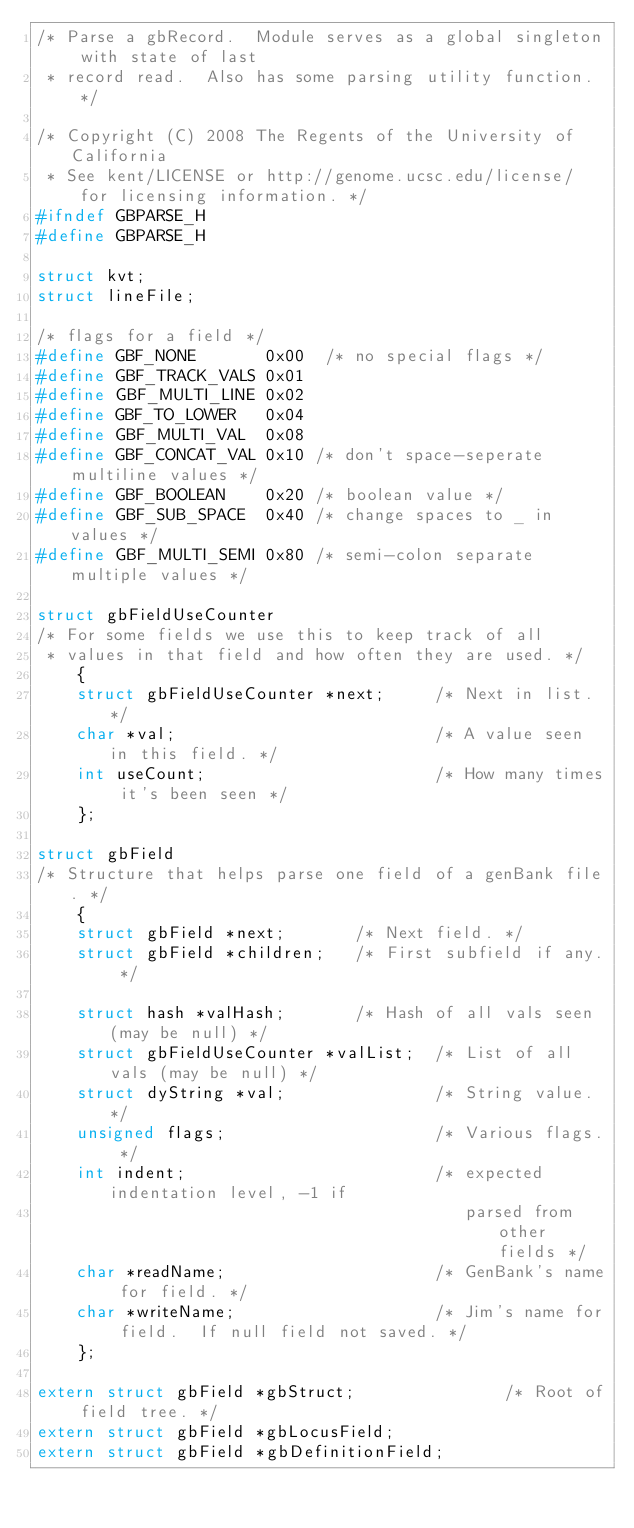Convert code to text. <code><loc_0><loc_0><loc_500><loc_500><_C_>/* Parse a gbRecord.  Module serves as a global singleton with state of last
 * record read.  Also has some parsing utility function. */

/* Copyright (C) 2008 The Regents of the University of California 
 * See kent/LICENSE or http://genome.ucsc.edu/license/ for licensing information. */
#ifndef GBPARSE_H
#define GBPARSE_H

struct kvt;
struct lineFile;

/* flags for a field */
#define GBF_NONE       0x00  /* no special flags */
#define GBF_TRACK_VALS 0x01
#define GBF_MULTI_LINE 0x02
#define GBF_TO_LOWER   0x04
#define GBF_MULTI_VAL  0x08
#define GBF_CONCAT_VAL 0x10 /* don't space-seperate multiline values */
#define GBF_BOOLEAN    0x20 /* boolean value */
#define GBF_SUB_SPACE  0x40 /* change spaces to _ in values */
#define GBF_MULTI_SEMI 0x80 /* semi-colon separate multiple values */

struct gbFieldUseCounter
/* For some fields we use this to keep track of all
 * values in that field and how often they are used. */
    {
    struct gbFieldUseCounter *next;     /* Next in list. */
    char *val;                          /* A value seen in this field. */
    int useCount;                       /* How many times it's been seen */
    };

struct gbField
/* Structure that helps parse one field of a genBank file. */    
    {
    struct gbField *next;       /* Next field. */
    struct gbField *children;   /* First subfield if any. */

    struct hash *valHash;       /* Hash of all vals seen (may be null) */
    struct gbFieldUseCounter *valList;  /* List of all vals (may be null) */
    struct dyString *val;               /* String value. */
    unsigned flags;                     /* Various flags. */
    int indent;                         /* expected indentation level, -1 if
                                           parsed from other fields */
    char *readName;                     /* GenBank's name for field. */
    char *writeName;                    /* Jim's name for field.  If null field not saved. */
    };

extern struct gbField *gbStruct;               /* Root of field tree. */
extern struct gbField *gbLocusField;     
extern struct gbField *gbDefinitionField;</code> 